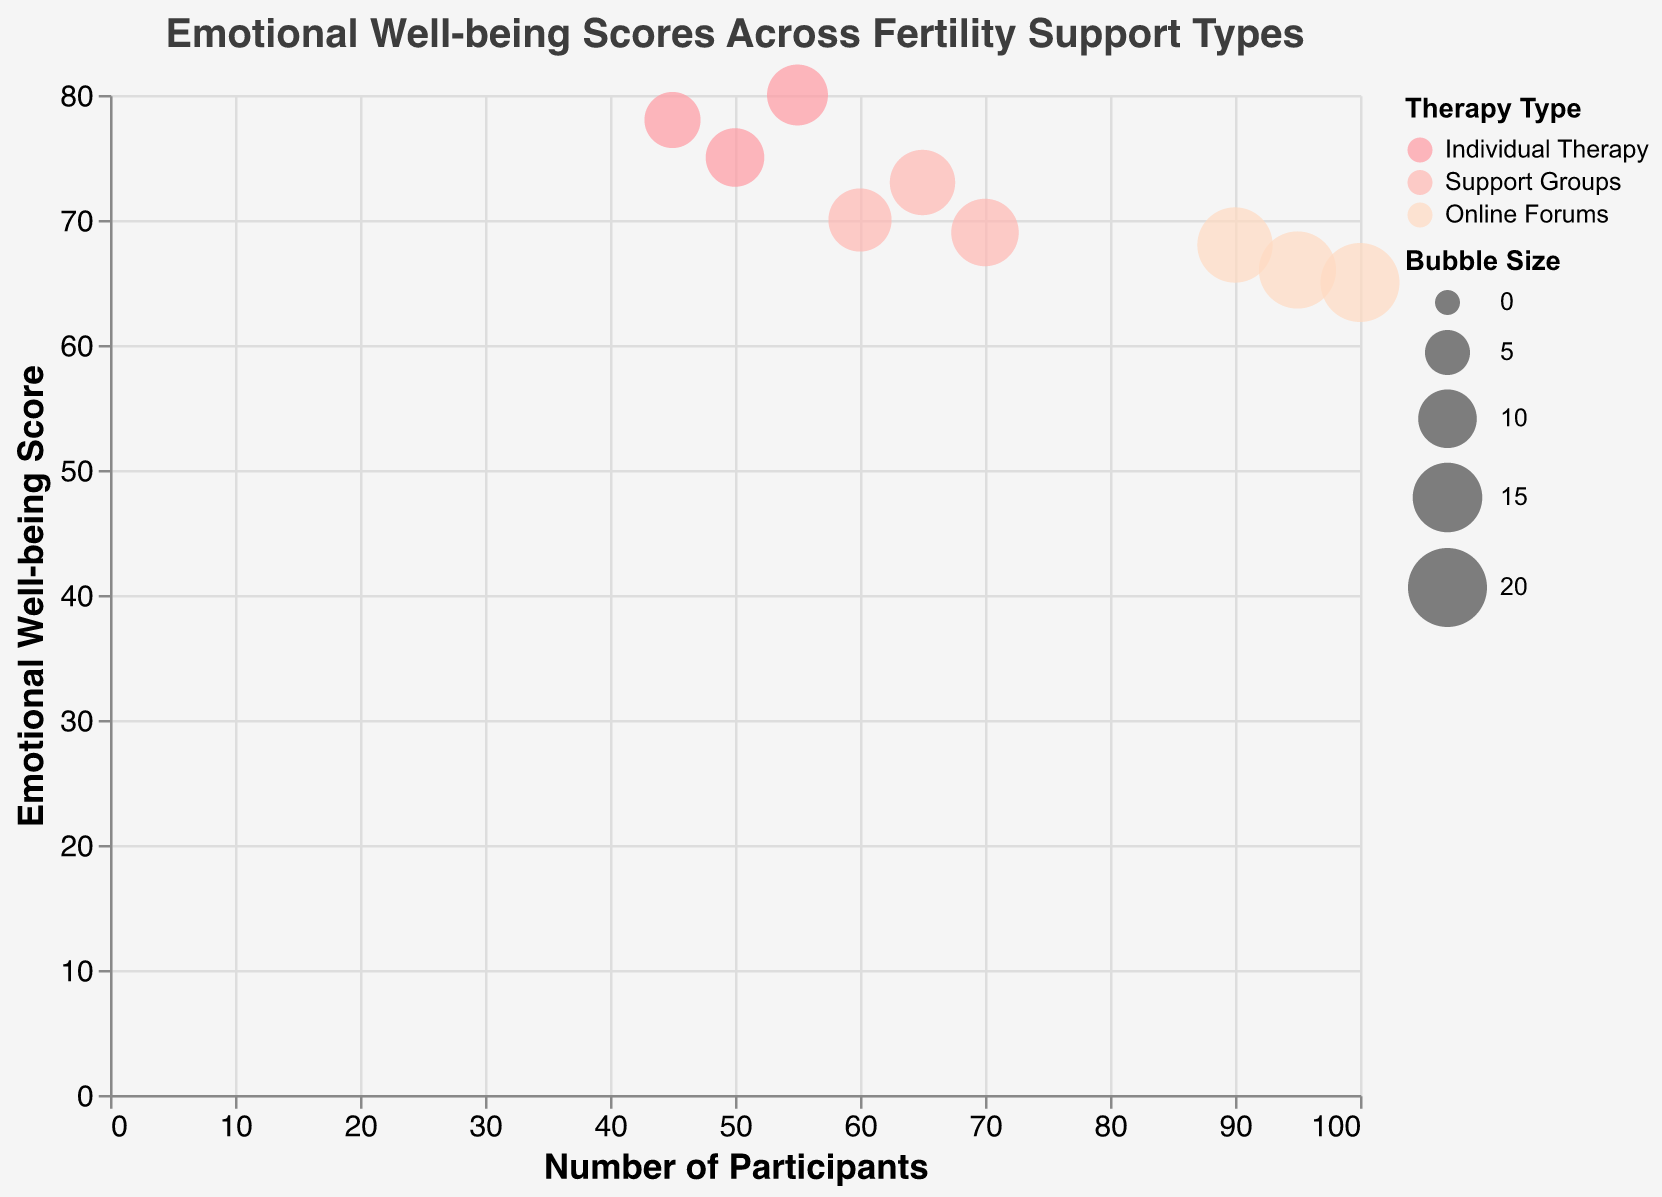What is the title of the figure? The title is typically found at the top of the figure. In this case, it reads "Emotional Well-being Scores Across Fertility Support Types".
Answer: Emotional Well-being Scores Across Fertility Support Types Which support type has the highest emotional well-being score? By looking at the highest point on the y-axis, which represents the emotional well-being score, we see the "Individual Therapy" bubble at 80.
Answer: Individual Therapy How many data points represent "Support Groups"? There are three bubbles for "Support Groups," each representing a distinct data point.
Answer: 3 What is the average emotional well-being score for "Online Forums"? Sum the emotional well-being scores for "Online Forums" (65, 68, and 66) and divide by 3. (65 + 68 + 66) / 3 = 199 / 3 = 66.33.
Answer: 66.33 What is the trend of emotional well-being scores as the number of participants increases in "Online Forums"? Observe the positioning of the bubbles for "Online Forums" on the graph. As the number of participants rises (from ~90 to ~100), the emotional well-being scores tend to stay in the mid-60s range, slightly increasing.
Answer: Slight increase Which support type has the largest number of participants? Look at the farthest point on the x-axis, representing the number of participants. "Online Forums" have the largest number of participants at 100.
Answer: Online Forums Which support type generally has the highest emotional well-being scores? By comparing the general positioning of bubbles on the y-axis, "Individual Therapy" generally has higher emotional well-being scores than "Support Groups" and "Online Forums".
Answer: Individual Therapy How does the emotional well-being score of the data point with the smallest number of participants compare to other scores? The smallest number of participants is 45 in "Individual Therapy" with a score of 78. Compare this to other scores; it is relatively high compared to many other bubbles.
Answer: Relatively high What is the bubble size for the data point with 55 participants in "Individual Therapy"? Identify the bubble for "Individual Therapy" with 55 participants and refer to its size value, which is 11.
Answer: 11 Are there any overlapping bubbles, and if so, which support types overlap? Look closely at the bubbles to see if any are partially or fully overlapping. There is slight overlap, but primarily, "Support Groups" and "Online Forums" barely overlap in certain areas.
Answer: Yes, slight overlap 